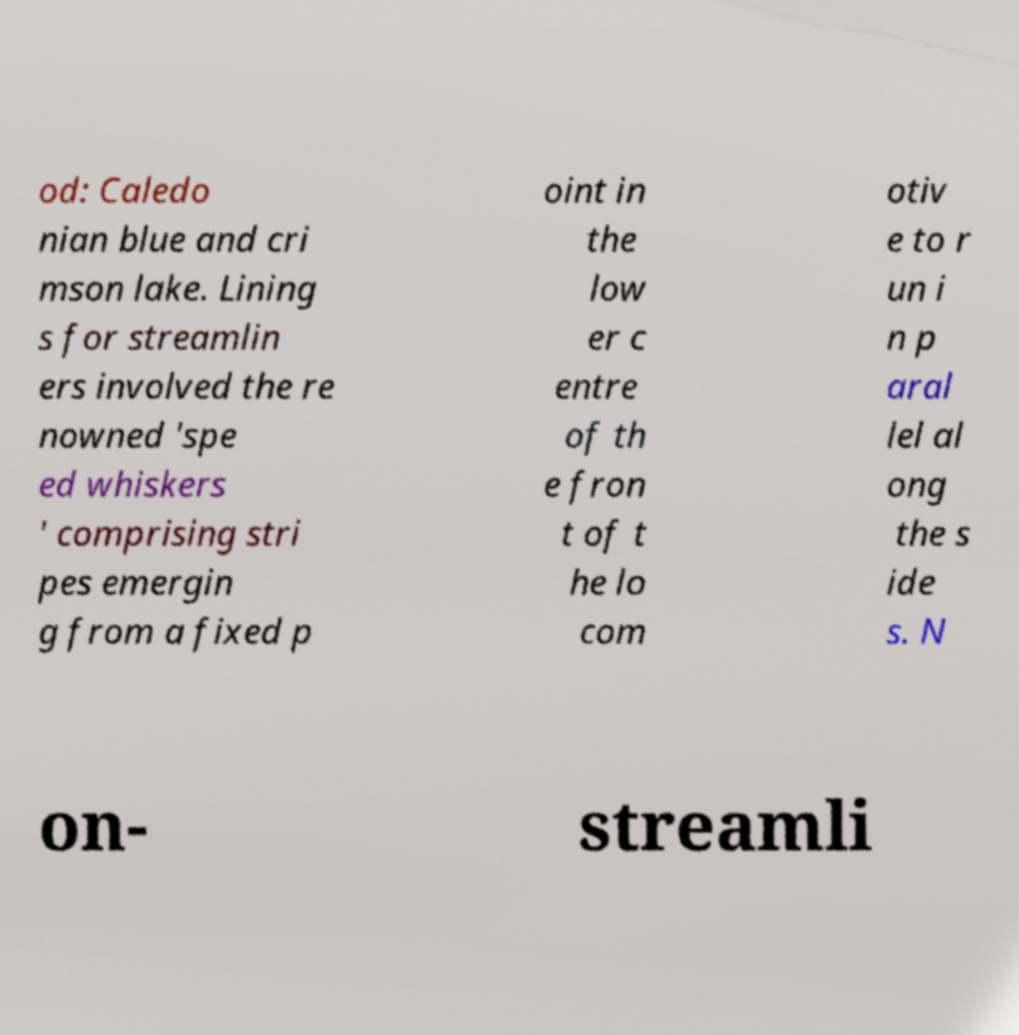There's text embedded in this image that I need extracted. Can you transcribe it verbatim? od: Caledo nian blue and cri mson lake. Lining s for streamlin ers involved the re nowned 'spe ed whiskers ' comprising stri pes emergin g from a fixed p oint in the low er c entre of th e fron t of t he lo com otiv e to r un i n p aral lel al ong the s ide s. N on- streamli 